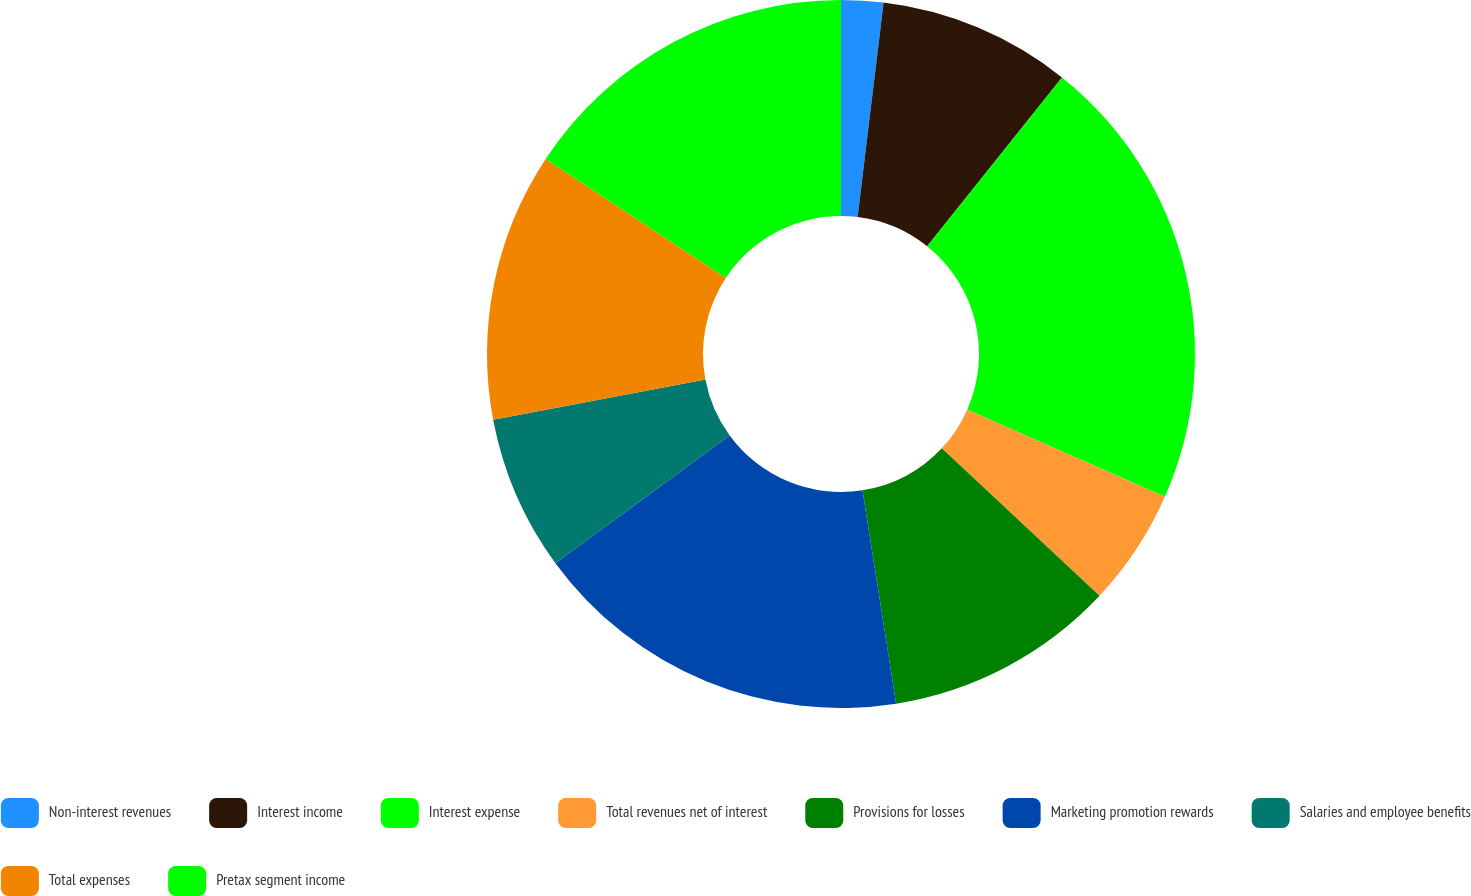Convert chart. <chart><loc_0><loc_0><loc_500><loc_500><pie_chart><fcel>Non-interest revenues<fcel>Interest income<fcel>Interest expense<fcel>Total revenues net of interest<fcel>Provisions for losses<fcel>Marketing promotion rewards<fcel>Salaries and employee benefits<fcel>Total expenses<fcel>Pretax segment income<nl><fcel>1.92%<fcel>8.81%<fcel>20.88%<fcel>5.36%<fcel>10.54%<fcel>17.43%<fcel>7.09%<fcel>12.26%<fcel>15.71%<nl></chart> 